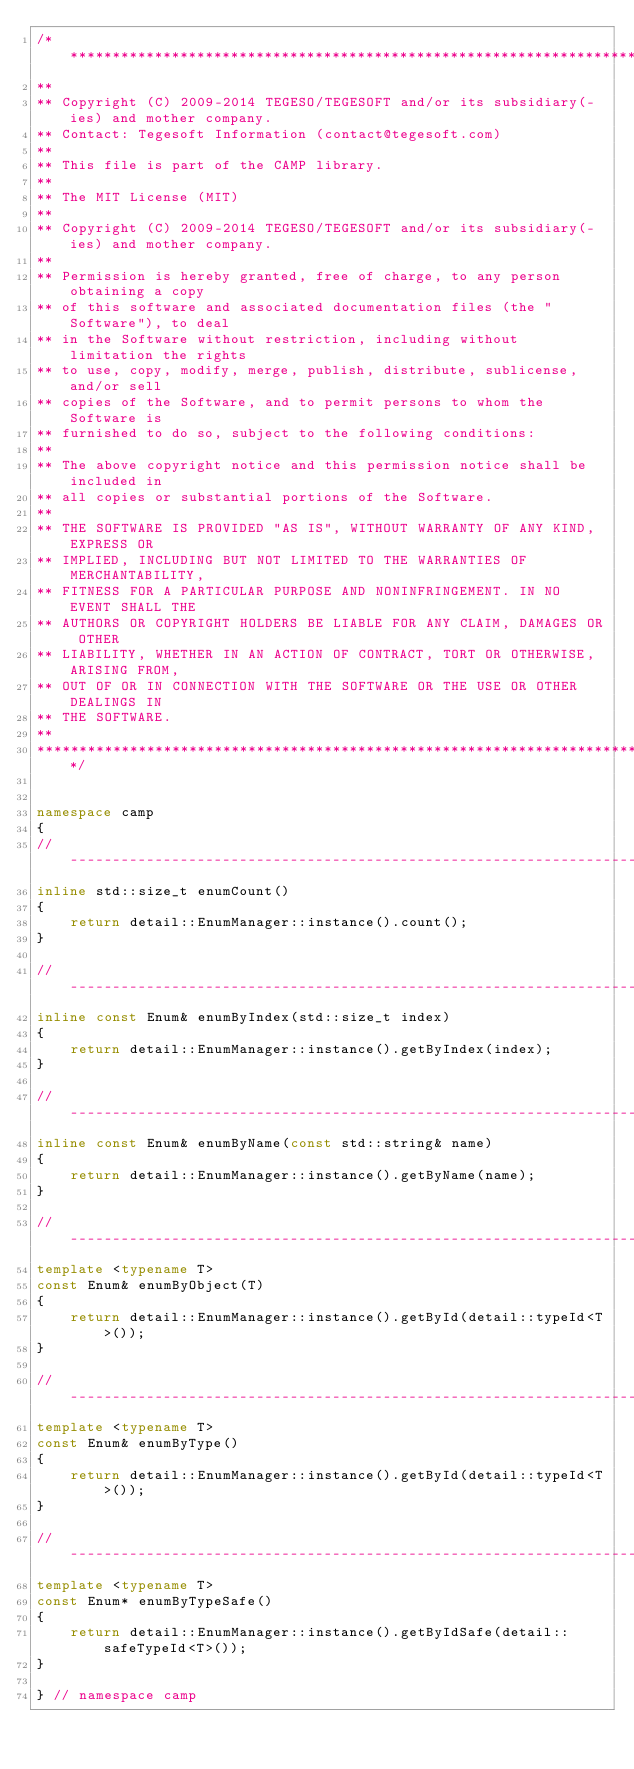Convert code to text. <code><loc_0><loc_0><loc_500><loc_500><_C++_>/****************************************************************************
**
** Copyright (C) 2009-2014 TEGESO/TEGESOFT and/or its subsidiary(-ies) and mother company.
** Contact: Tegesoft Information (contact@tegesoft.com)
**
** This file is part of the CAMP library.
**
** The MIT License (MIT)
**
** Copyright (C) 2009-2014 TEGESO/TEGESOFT and/or its subsidiary(-ies) and mother company.
**
** Permission is hereby granted, free of charge, to any person obtaining a copy
** of this software and associated documentation files (the "Software"), to deal
** in the Software without restriction, including without limitation the rights
** to use, copy, modify, merge, publish, distribute, sublicense, and/or sell
** copies of the Software, and to permit persons to whom the Software is
** furnished to do so, subject to the following conditions:
** 
** The above copyright notice and this permission notice shall be included in
** all copies or substantial portions of the Software.
** 
** THE SOFTWARE IS PROVIDED "AS IS", WITHOUT WARRANTY OF ANY KIND, EXPRESS OR
** IMPLIED, INCLUDING BUT NOT LIMITED TO THE WARRANTIES OF MERCHANTABILITY,
** FITNESS FOR A PARTICULAR PURPOSE AND NONINFRINGEMENT. IN NO EVENT SHALL THE
** AUTHORS OR COPYRIGHT HOLDERS BE LIABLE FOR ANY CLAIM, DAMAGES OR OTHER
** LIABILITY, WHETHER IN AN ACTION OF CONTRACT, TORT OR OTHERWISE, ARISING FROM,
** OUT OF OR IN CONNECTION WITH THE SOFTWARE OR THE USE OR OTHER DEALINGS IN
** THE SOFTWARE.
**
****************************************************************************/


namespace camp
{
//-------------------------------------------------------------------------------------------------
inline std::size_t enumCount()
{
    return detail::EnumManager::instance().count();
}

//-------------------------------------------------------------------------------------------------
inline const Enum& enumByIndex(std::size_t index)
{
    return detail::EnumManager::instance().getByIndex(index);
}

//-------------------------------------------------------------------------------------------------
inline const Enum& enumByName(const std::string& name)
{
    return detail::EnumManager::instance().getByName(name);
}

//-------------------------------------------------------------------------------------------------
template <typename T>
const Enum& enumByObject(T)
{
    return detail::EnumManager::instance().getById(detail::typeId<T>());
}

//-------------------------------------------------------------------------------------------------
template <typename T>
const Enum& enumByType()
{
    return detail::EnumManager::instance().getById(detail::typeId<T>());
}

//-------------------------------------------------------------------------------------------------
template <typename T>
const Enum* enumByTypeSafe()
{
    return detail::EnumManager::instance().getByIdSafe(detail::safeTypeId<T>());
}

} // namespace camp
</code> 